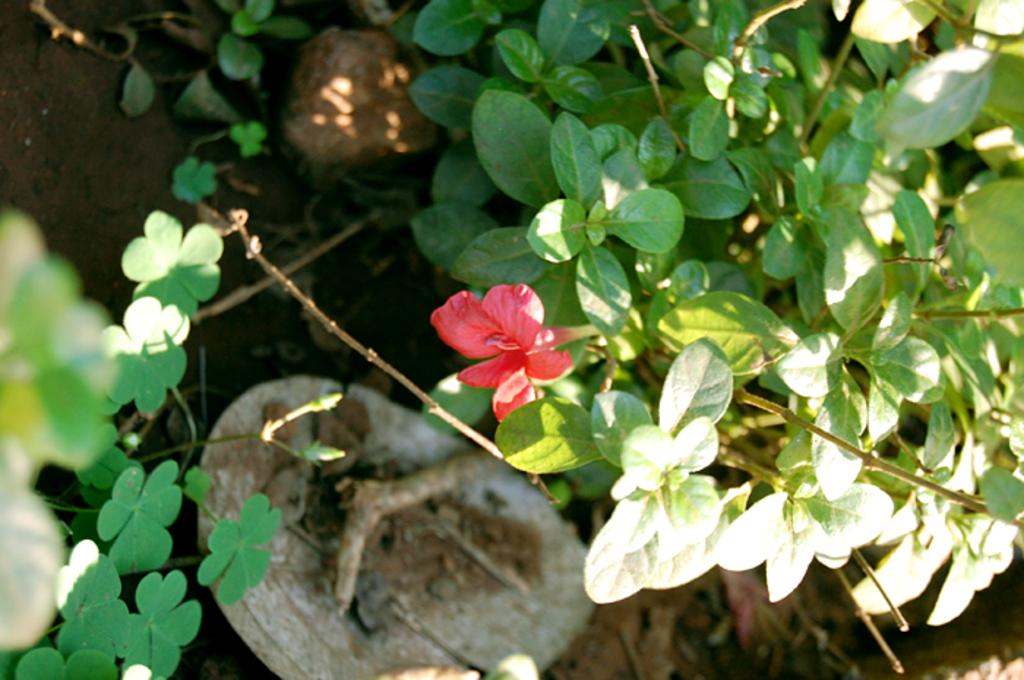What is present in the image? There is a plant in the image. What distinguishing feature can be observed on the plant? The plant has a red-colored flower. How does the plant push itself into space in the image? The plant does not push itself into space in the image; it is stationary and located on Earth. What type of finger can be seen on the plant in the image? There are no fingers present on the plant in the image, as fingers are a characteristic of animals and humans, not plants. 